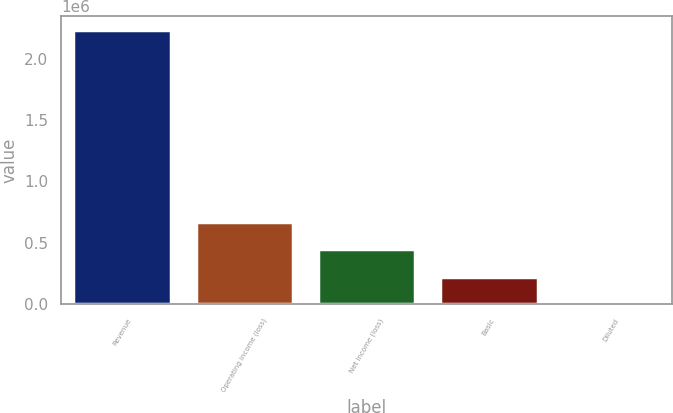<chart> <loc_0><loc_0><loc_500><loc_500><bar_chart><fcel>Revenue<fcel>Operating income (loss)<fcel>Net income (loss)<fcel>Basic<fcel>Diluted<nl><fcel>2.23759e+06<fcel>671276<fcel>447518<fcel>223759<fcel>0.7<nl></chart> 